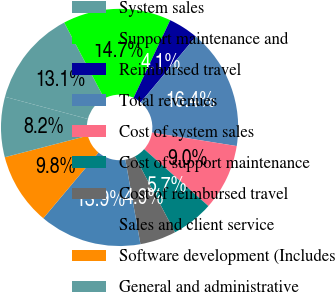Convert chart. <chart><loc_0><loc_0><loc_500><loc_500><pie_chart><fcel>System sales<fcel>Support maintenance and<fcel>Reimbursed travel<fcel>Total revenues<fcel>Cost of system sales<fcel>Cost of support maintenance<fcel>Cost of reimbursed travel<fcel>Sales and client service<fcel>Software development (Includes<fcel>General and administrative<nl><fcel>13.11%<fcel>14.75%<fcel>4.1%<fcel>16.39%<fcel>9.02%<fcel>5.74%<fcel>4.92%<fcel>13.93%<fcel>9.84%<fcel>8.2%<nl></chart> 